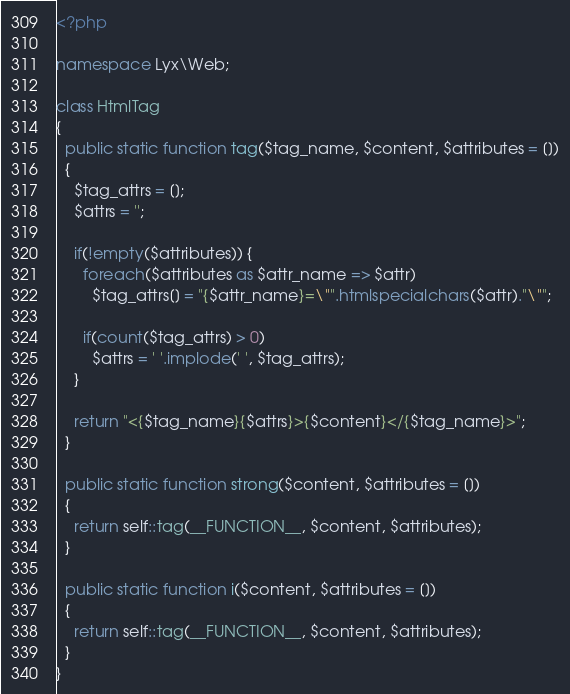Convert code to text. <code><loc_0><loc_0><loc_500><loc_500><_PHP_><?php

namespace Lyx\Web;

class HtmlTag
{
  public static function tag($tag_name, $content, $attributes = [])
  {
    $tag_attrs = [];
    $attrs = '';

    if(!empty($attributes)) {
      foreach($attributes as $attr_name => $attr)
        $tag_attrs[] = "{$attr_name}=\"".htmlspecialchars($attr)."\"";
      
      if(count($tag_attrs) > 0)
        $attrs = ' '.implode(' ', $tag_attrs); 
    }

    return "<{$tag_name}{$attrs}>{$content}</{$tag_name}>";
  }
  
  public static function strong($content, $attributes = [])
  {
    return self::tag(__FUNCTION__, $content, $attributes);
  }
  
  public static function i($content, $attributes = [])
  {
    return self::tag(__FUNCTION__, $content, $attributes);
  }
}
</code> 